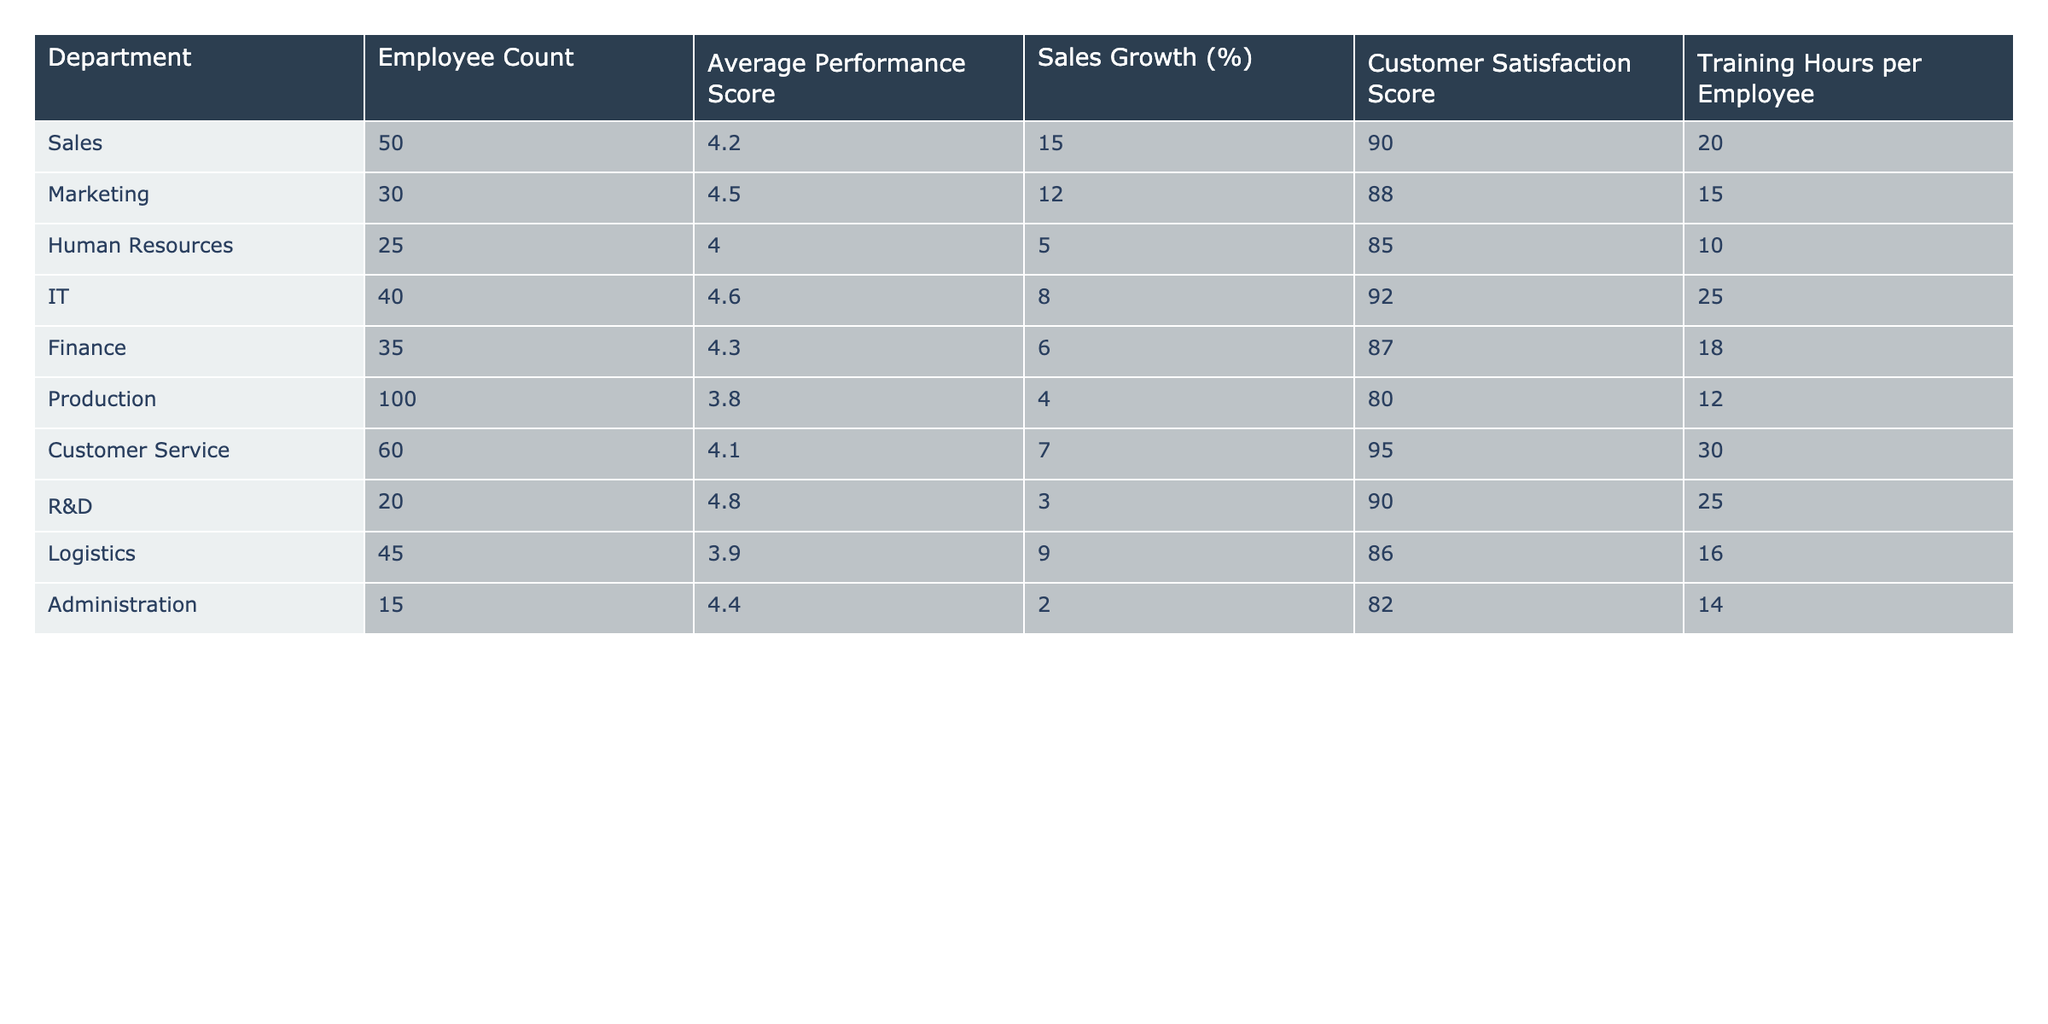What's the average performance score of the Sales department? The average performance score for the Sales department is listed directly in the table as 4.2.
Answer: 4.2 Which department has the highest average performance score? The average performance scores for each department are listed in the table. Upon reviewing, IT has the highest score at 4.6.
Answer: IT How many training hours per employee does the Customer Service department provide? The table shows that the Customer Service department provides 30 training hours per employee.
Answer: 30 What is the sales growth percentage for the Marketing department? The sales growth percentage for the Marketing department is noted in the table as 12%.
Answer: 12% Is the average performance score for the Production department above or below 4.0? The average performance score for the Production department is 3.8, which is below 4.0.
Answer: Below Which department has the lowest customer satisfaction score? The customer satisfaction scores are listed in the table. Production has the lowest score at 80.
Answer: Production What is the total employee count for the IT and R&D departments combined? The employee count for IT is 40 and for R&D it is 20. Adding these gives 40 + 20 = 60 employees.
Answer: 60 If we average the training hours per employee for the IT and Customer Service departments, what result do we get? The training hours for IT are 25 and for Customer Service are 30. Adding them gives 25 + 30 = 55, and dividing by 2 results in an average of 27.5 hours.
Answer: 27.5 Does the Marketing department have a customer satisfaction score higher than 85? The customer satisfaction score for Marketing is 88, which is indeed higher than 85.
Answer: Yes Which department has a higher sales growth percentage: Finance or Logistics? The sales growth percentage for Finance is 6% and for Logistics is 9%. Therefore, Logistics has the higher percentage.
Answer: Logistics What is the difference in average performance score between the highest and lowest scoring departments? The highest average performance score is 4.8 (R&D) and the lowest is 3.8 (Production). The difference is 4.8 - 3.8 = 1.0.
Answer: 1.0 